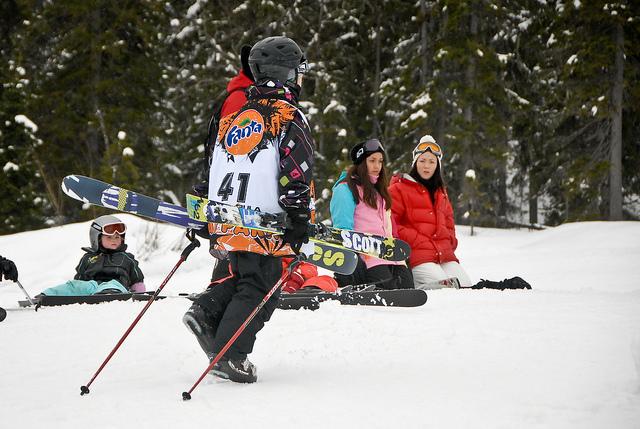Is it cold outside?
Give a very brief answer. Yes. Why are most of the kids sitting?
Write a very short answer. Resting. What brand soda is on the kids jacket?
Concise answer only. Fanta. What is the pink thing behind the skier?
Write a very short answer. Jacket. What two numbers are repeated on his Jersey?
Be succinct. 41. 